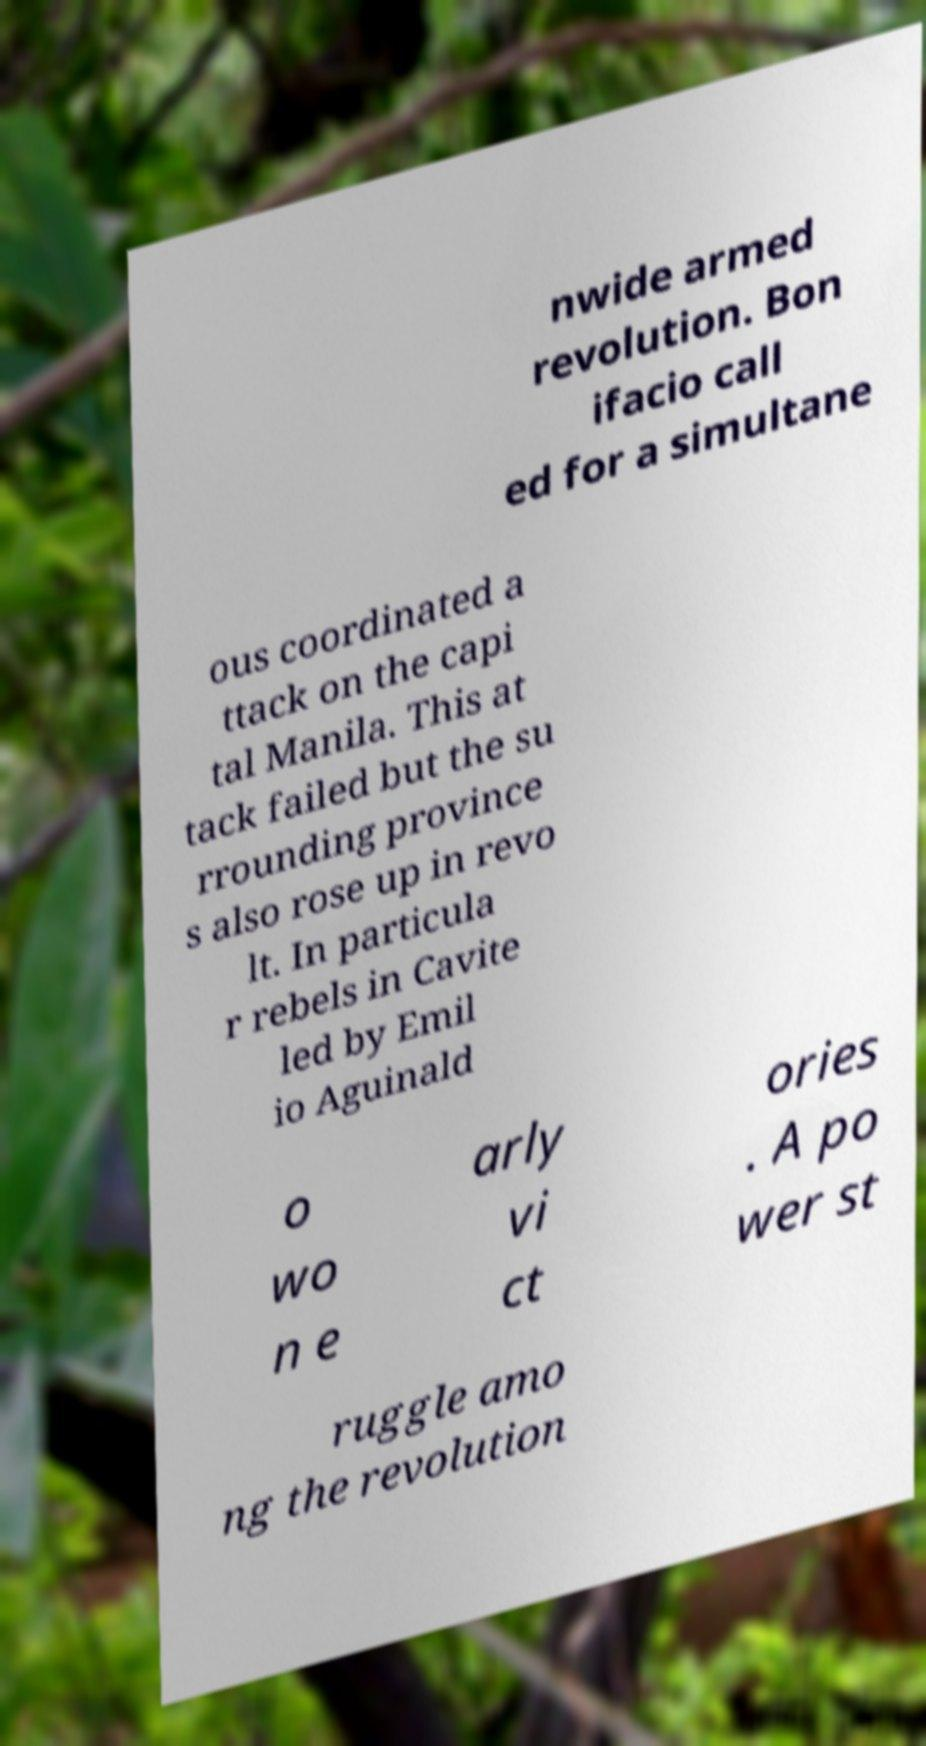For documentation purposes, I need the text within this image transcribed. Could you provide that? nwide armed revolution. Bon ifacio call ed for a simultane ous coordinated a ttack on the capi tal Manila. This at tack failed but the su rrounding province s also rose up in revo lt. In particula r rebels in Cavite led by Emil io Aguinald o wo n e arly vi ct ories . A po wer st ruggle amo ng the revolution 